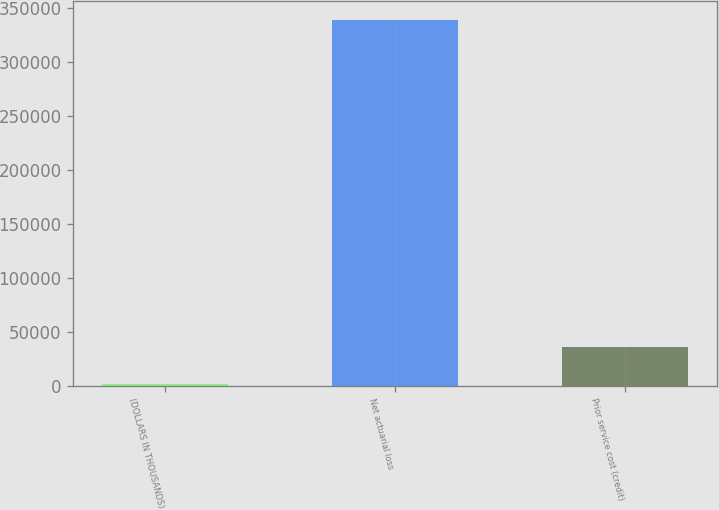Convert chart to OTSL. <chart><loc_0><loc_0><loc_500><loc_500><bar_chart><fcel>(DOLLARS IN THOUSANDS)<fcel>Net actuarial loss<fcel>Prior service cost (credit)<nl><fcel>2017<fcel>338916<fcel>35706.9<nl></chart> 